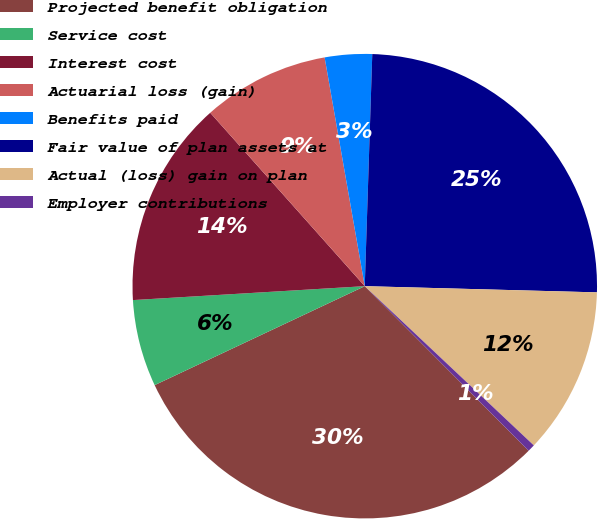<chart> <loc_0><loc_0><loc_500><loc_500><pie_chart><fcel>Projected benefit obligation<fcel>Service cost<fcel>Interest cost<fcel>Actuarial loss (gain)<fcel>Benefits paid<fcel>Fair value of plan assets at<fcel>Actual (loss) gain on plan<fcel>Employer contributions<nl><fcel>30.46%<fcel>6.05%<fcel>14.37%<fcel>8.82%<fcel>3.28%<fcel>24.91%<fcel>11.6%<fcel>0.51%<nl></chart> 